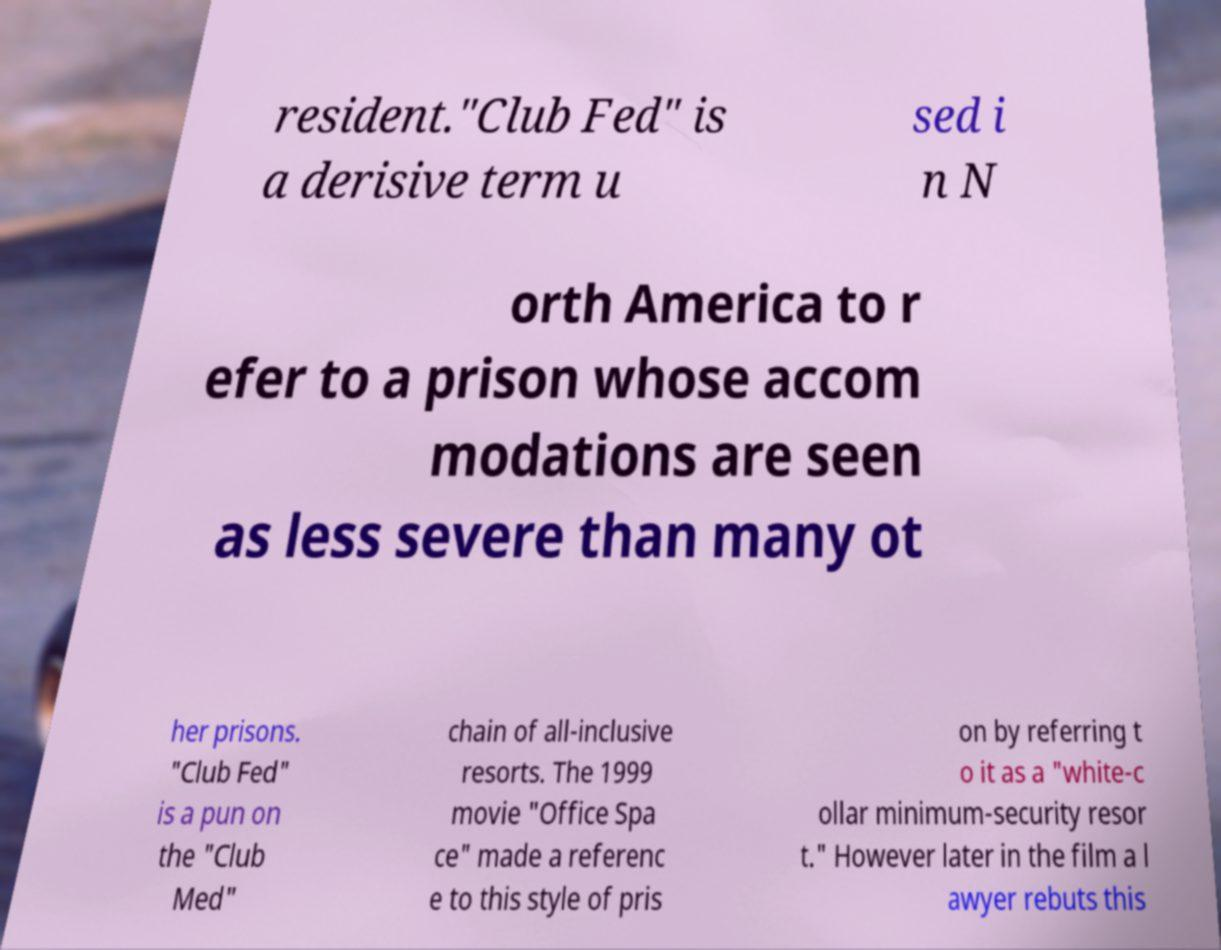Can you accurately transcribe the text from the provided image for me? resident."Club Fed" is a derisive term u sed i n N orth America to r efer to a prison whose accom modations are seen as less severe than many ot her prisons. "Club Fed" is a pun on the "Club Med" chain of all-inclusive resorts. The 1999 movie "Office Spa ce" made a referenc e to this style of pris on by referring t o it as a "white-c ollar minimum-security resor t." However later in the film a l awyer rebuts this 